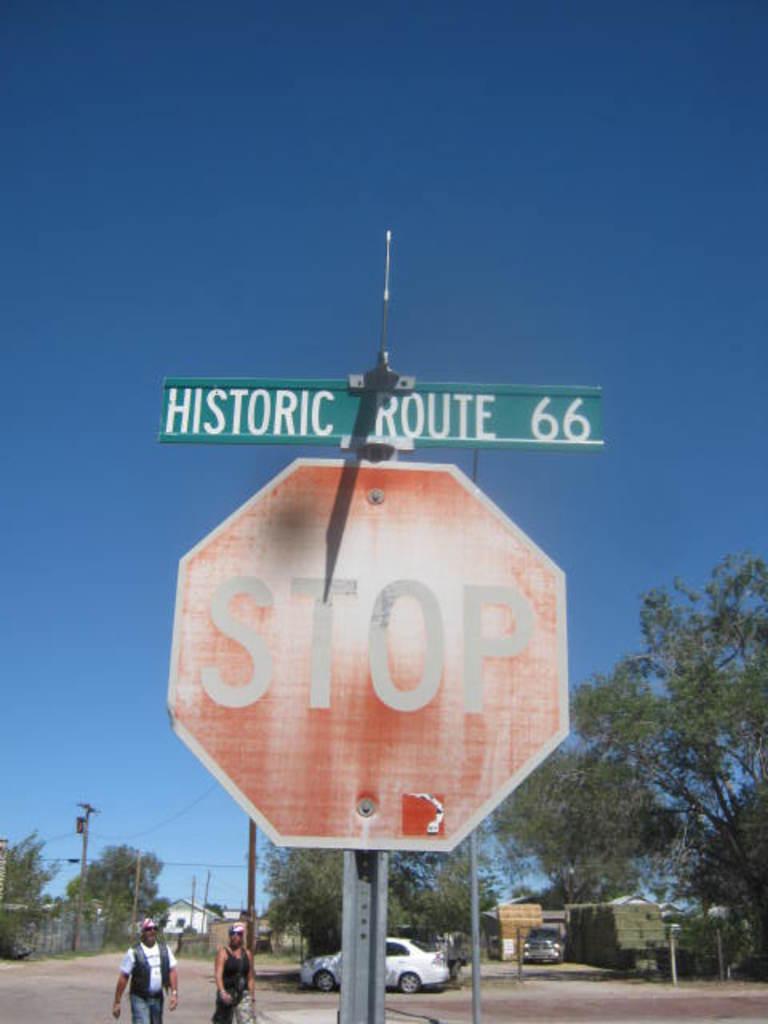What is the route number?
Your response must be concise. 66. What is the road name?
Your answer should be compact. Historic route 66. 